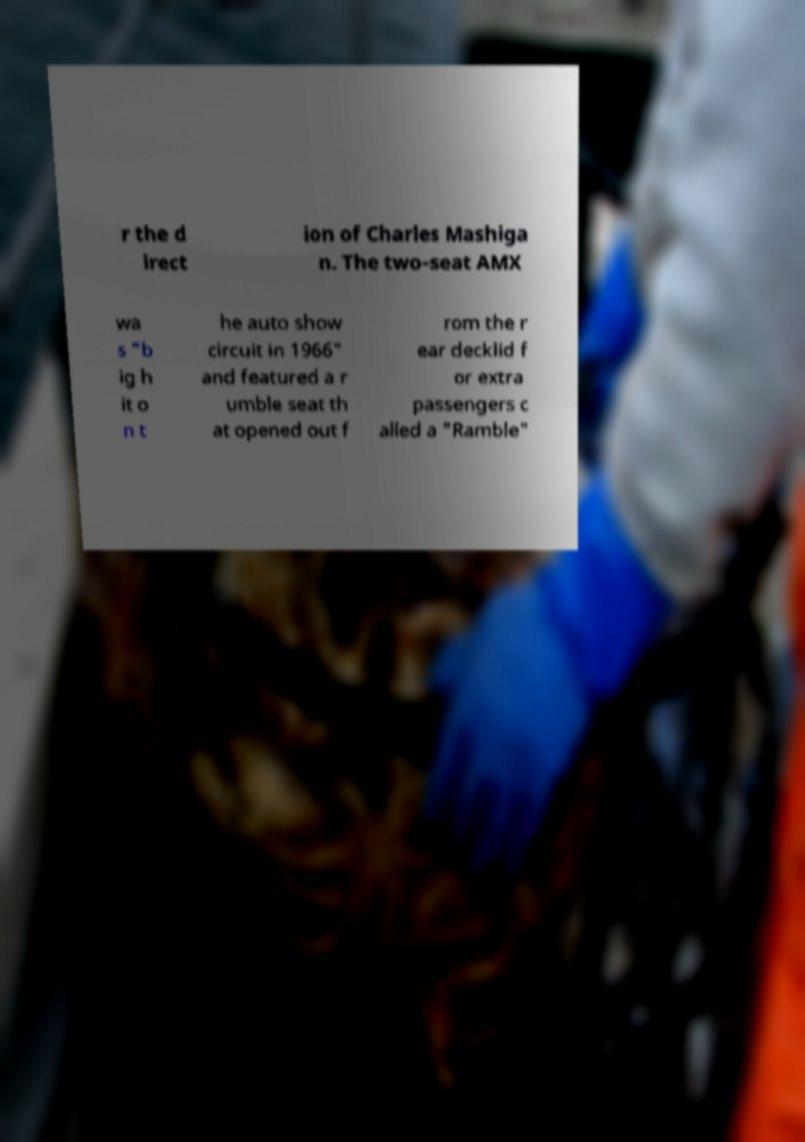Can you accurately transcribe the text from the provided image for me? r the d irect ion of Charles Mashiga n. The two-seat AMX wa s "b ig h it o n t he auto show circuit in 1966" and featured a r umble seat th at opened out f rom the r ear decklid f or extra passengers c alled a "Ramble" 